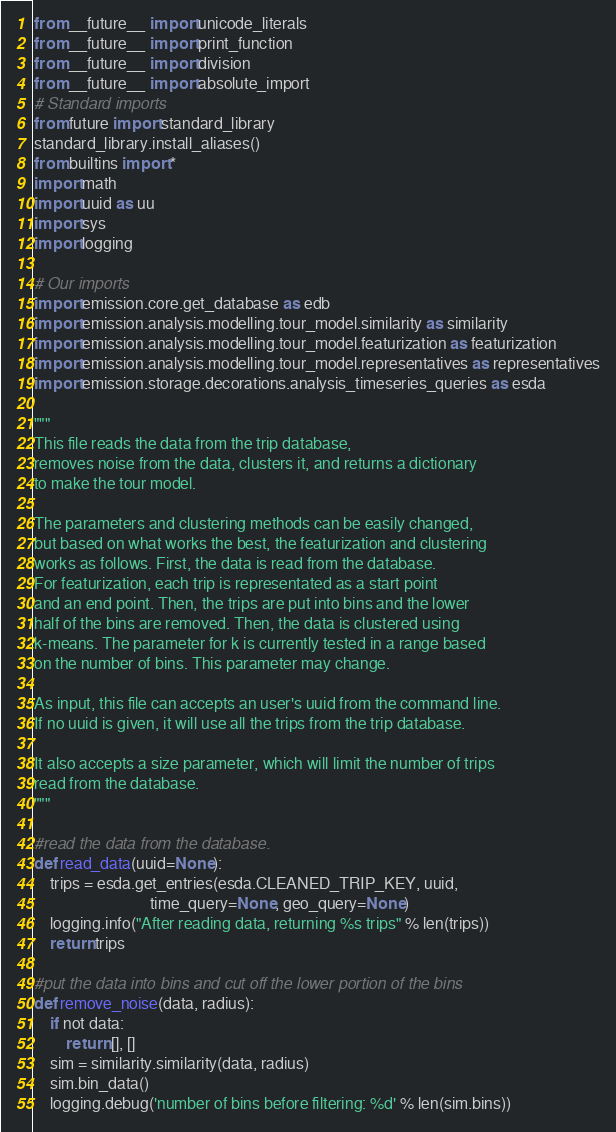<code> <loc_0><loc_0><loc_500><loc_500><_Python_>from __future__ import unicode_literals
from __future__ import print_function
from __future__ import division
from __future__ import absolute_import
# Standard imports
from future import standard_library
standard_library.install_aliases()
from builtins import *
import math
import uuid as uu
import sys
import logging

# Our imports
import emission.core.get_database as edb
import emission.analysis.modelling.tour_model.similarity as similarity
import emission.analysis.modelling.tour_model.featurization as featurization
import emission.analysis.modelling.tour_model.representatives as representatives
import emission.storage.decorations.analysis_timeseries_queries as esda

"""
This file reads the data from the trip database, 
removes noise from the data, clusters it, and returns a dictionary 
to make the tour model. 

The parameters and clustering methods can be easily changed, 
but based on what works the best, the featurization and clustering 
works as follows. First, the data is read from the database. 
For featurization, each trip is representated as a start point 
and an end point. Then, the trips are put into bins and the lower 
half of the bins are removed. Then, the data is clustered using 
k-means. The parameter for k is currently tested in a range based 
on the number of bins. This parameter may change.

As input, this file can accepts an user's uuid from the command line. 
If no uuid is given, it will use all the trips from the trip database.

It also accepts a size parameter, which will limit the number of trips 
read from the database. 
"""

#read the data from the database. 
def read_data(uuid=None):
    trips = esda.get_entries(esda.CLEANED_TRIP_KEY, uuid,
                             time_query=None, geo_query=None)
    logging.info("After reading data, returning %s trips" % len(trips))
    return trips

#put the data into bins and cut off the lower portion of the bins
def remove_noise(data, radius):
    if not data:
        return [], []
    sim = similarity.similarity(data, radius)
    sim.bin_data()
    logging.debug('number of bins before filtering: %d' % len(sim.bins))</code> 